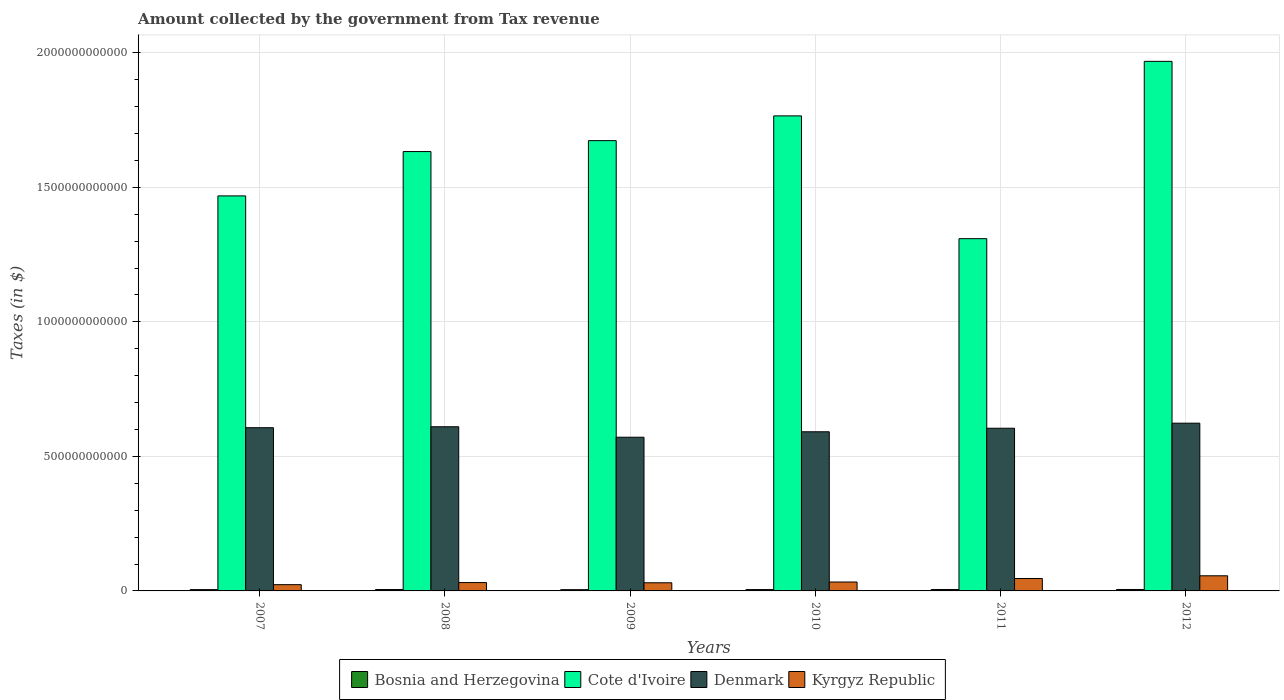How many different coloured bars are there?
Offer a terse response. 4. Are the number of bars per tick equal to the number of legend labels?
Provide a short and direct response. Yes. What is the label of the 3rd group of bars from the left?
Your answer should be very brief. 2009. In how many cases, is the number of bars for a given year not equal to the number of legend labels?
Your answer should be very brief. 0. What is the amount collected by the government from tax revenue in Cote d'Ivoire in 2007?
Your response must be concise. 1.47e+12. Across all years, what is the maximum amount collected by the government from tax revenue in Cote d'Ivoire?
Provide a short and direct response. 1.97e+12. Across all years, what is the minimum amount collected by the government from tax revenue in Kyrgyz Republic?
Ensure brevity in your answer.  2.33e+1. In which year was the amount collected by the government from tax revenue in Cote d'Ivoire maximum?
Give a very brief answer. 2012. In which year was the amount collected by the government from tax revenue in Cote d'Ivoire minimum?
Give a very brief answer. 2011. What is the total amount collected by the government from tax revenue in Cote d'Ivoire in the graph?
Your answer should be very brief. 9.82e+12. What is the difference between the amount collected by the government from tax revenue in Denmark in 2010 and that in 2011?
Make the answer very short. -1.31e+1. What is the difference between the amount collected by the government from tax revenue in Bosnia and Herzegovina in 2007 and the amount collected by the government from tax revenue in Cote d'Ivoire in 2009?
Your answer should be very brief. -1.67e+12. What is the average amount collected by the government from tax revenue in Cote d'Ivoire per year?
Give a very brief answer. 1.64e+12. In the year 2010, what is the difference between the amount collected by the government from tax revenue in Denmark and amount collected by the government from tax revenue in Kyrgyz Republic?
Provide a succinct answer. 5.58e+11. In how many years, is the amount collected by the government from tax revenue in Kyrgyz Republic greater than 1200000000000 $?
Provide a short and direct response. 0. What is the ratio of the amount collected by the government from tax revenue in Cote d'Ivoire in 2009 to that in 2011?
Keep it short and to the point. 1.28. Is the amount collected by the government from tax revenue in Kyrgyz Republic in 2010 less than that in 2011?
Your response must be concise. Yes. What is the difference between the highest and the second highest amount collected by the government from tax revenue in Cote d'Ivoire?
Make the answer very short. 2.03e+11. What is the difference between the highest and the lowest amount collected by the government from tax revenue in Kyrgyz Republic?
Your response must be concise. 3.30e+1. In how many years, is the amount collected by the government from tax revenue in Kyrgyz Republic greater than the average amount collected by the government from tax revenue in Kyrgyz Republic taken over all years?
Give a very brief answer. 2. Is the sum of the amount collected by the government from tax revenue in Kyrgyz Republic in 2009 and 2011 greater than the maximum amount collected by the government from tax revenue in Denmark across all years?
Make the answer very short. No. Is it the case that in every year, the sum of the amount collected by the government from tax revenue in Denmark and amount collected by the government from tax revenue in Cote d'Ivoire is greater than the sum of amount collected by the government from tax revenue in Kyrgyz Republic and amount collected by the government from tax revenue in Bosnia and Herzegovina?
Keep it short and to the point. Yes. What does the 1st bar from the left in 2007 represents?
Make the answer very short. Bosnia and Herzegovina. What does the 1st bar from the right in 2010 represents?
Keep it short and to the point. Kyrgyz Republic. Is it the case that in every year, the sum of the amount collected by the government from tax revenue in Denmark and amount collected by the government from tax revenue in Bosnia and Herzegovina is greater than the amount collected by the government from tax revenue in Kyrgyz Republic?
Make the answer very short. Yes. How many years are there in the graph?
Keep it short and to the point. 6. What is the difference between two consecutive major ticks on the Y-axis?
Provide a short and direct response. 5.00e+11. Are the values on the major ticks of Y-axis written in scientific E-notation?
Give a very brief answer. No. Does the graph contain grids?
Make the answer very short. Yes. Where does the legend appear in the graph?
Offer a very short reply. Bottom center. How are the legend labels stacked?
Make the answer very short. Horizontal. What is the title of the graph?
Your response must be concise. Amount collected by the government from Tax revenue. What is the label or title of the Y-axis?
Provide a short and direct response. Taxes (in $). What is the Taxes (in $) of Bosnia and Herzegovina in 2007?
Provide a succinct answer. 4.82e+09. What is the Taxes (in $) in Cote d'Ivoire in 2007?
Ensure brevity in your answer.  1.47e+12. What is the Taxes (in $) of Denmark in 2007?
Your response must be concise. 6.07e+11. What is the Taxes (in $) of Kyrgyz Republic in 2007?
Ensure brevity in your answer.  2.33e+1. What is the Taxes (in $) in Bosnia and Herzegovina in 2008?
Your response must be concise. 5.18e+09. What is the Taxes (in $) of Cote d'Ivoire in 2008?
Provide a succinct answer. 1.63e+12. What is the Taxes (in $) in Denmark in 2008?
Offer a terse response. 6.10e+11. What is the Taxes (in $) in Kyrgyz Republic in 2008?
Offer a terse response. 3.10e+1. What is the Taxes (in $) of Bosnia and Herzegovina in 2009?
Your answer should be compact. 4.70e+09. What is the Taxes (in $) of Cote d'Ivoire in 2009?
Offer a very short reply. 1.67e+12. What is the Taxes (in $) of Denmark in 2009?
Your answer should be very brief. 5.71e+11. What is the Taxes (in $) of Kyrgyz Republic in 2009?
Offer a terse response. 3.03e+1. What is the Taxes (in $) in Bosnia and Herzegovina in 2010?
Your answer should be very brief. 4.99e+09. What is the Taxes (in $) in Cote d'Ivoire in 2010?
Your answer should be very brief. 1.77e+12. What is the Taxes (in $) in Denmark in 2010?
Make the answer very short. 5.91e+11. What is the Taxes (in $) of Kyrgyz Republic in 2010?
Your answer should be compact. 3.31e+1. What is the Taxes (in $) in Bosnia and Herzegovina in 2011?
Provide a short and direct response. 5.33e+09. What is the Taxes (in $) in Cote d'Ivoire in 2011?
Offer a terse response. 1.31e+12. What is the Taxes (in $) of Denmark in 2011?
Keep it short and to the point. 6.05e+11. What is the Taxes (in $) in Kyrgyz Republic in 2011?
Your response must be concise. 4.61e+1. What is the Taxes (in $) in Bosnia and Herzegovina in 2012?
Your answer should be compact. 5.37e+09. What is the Taxes (in $) in Cote d'Ivoire in 2012?
Make the answer very short. 1.97e+12. What is the Taxes (in $) in Denmark in 2012?
Keep it short and to the point. 6.23e+11. What is the Taxes (in $) of Kyrgyz Republic in 2012?
Provide a succinct answer. 5.62e+1. Across all years, what is the maximum Taxes (in $) in Bosnia and Herzegovina?
Provide a short and direct response. 5.37e+09. Across all years, what is the maximum Taxes (in $) of Cote d'Ivoire?
Provide a succinct answer. 1.97e+12. Across all years, what is the maximum Taxes (in $) in Denmark?
Provide a short and direct response. 6.23e+11. Across all years, what is the maximum Taxes (in $) of Kyrgyz Republic?
Offer a terse response. 5.62e+1. Across all years, what is the minimum Taxes (in $) of Bosnia and Herzegovina?
Your response must be concise. 4.70e+09. Across all years, what is the minimum Taxes (in $) of Cote d'Ivoire?
Offer a very short reply. 1.31e+12. Across all years, what is the minimum Taxes (in $) of Denmark?
Your answer should be very brief. 5.71e+11. Across all years, what is the minimum Taxes (in $) of Kyrgyz Republic?
Offer a terse response. 2.33e+1. What is the total Taxes (in $) in Bosnia and Herzegovina in the graph?
Make the answer very short. 3.04e+1. What is the total Taxes (in $) of Cote d'Ivoire in the graph?
Give a very brief answer. 9.82e+12. What is the total Taxes (in $) in Denmark in the graph?
Your answer should be very brief. 3.61e+12. What is the total Taxes (in $) of Kyrgyz Republic in the graph?
Provide a short and direct response. 2.20e+11. What is the difference between the Taxes (in $) of Bosnia and Herzegovina in 2007 and that in 2008?
Your answer should be compact. -3.57e+08. What is the difference between the Taxes (in $) of Cote d'Ivoire in 2007 and that in 2008?
Offer a terse response. -1.65e+11. What is the difference between the Taxes (in $) in Denmark in 2007 and that in 2008?
Provide a succinct answer. -3.56e+09. What is the difference between the Taxes (in $) in Kyrgyz Republic in 2007 and that in 2008?
Make the answer very short. -7.77e+09. What is the difference between the Taxes (in $) in Bosnia and Herzegovina in 2007 and that in 2009?
Offer a terse response. 1.26e+08. What is the difference between the Taxes (in $) in Cote d'Ivoire in 2007 and that in 2009?
Your answer should be compact. -2.05e+11. What is the difference between the Taxes (in $) of Denmark in 2007 and that in 2009?
Give a very brief answer. 3.54e+1. What is the difference between the Taxes (in $) of Kyrgyz Republic in 2007 and that in 2009?
Your answer should be compact. -6.99e+09. What is the difference between the Taxes (in $) of Bosnia and Herzegovina in 2007 and that in 2010?
Give a very brief answer. -1.69e+08. What is the difference between the Taxes (in $) of Cote d'Ivoire in 2007 and that in 2010?
Provide a short and direct response. -2.97e+11. What is the difference between the Taxes (in $) of Denmark in 2007 and that in 2010?
Offer a very short reply. 1.51e+1. What is the difference between the Taxes (in $) of Kyrgyz Republic in 2007 and that in 2010?
Keep it short and to the point. -9.86e+09. What is the difference between the Taxes (in $) of Bosnia and Herzegovina in 2007 and that in 2011?
Give a very brief answer. -5.02e+08. What is the difference between the Taxes (in $) of Cote d'Ivoire in 2007 and that in 2011?
Make the answer very short. 1.59e+11. What is the difference between the Taxes (in $) in Denmark in 2007 and that in 2011?
Your answer should be very brief. 1.95e+09. What is the difference between the Taxes (in $) in Kyrgyz Republic in 2007 and that in 2011?
Give a very brief answer. -2.29e+1. What is the difference between the Taxes (in $) of Bosnia and Herzegovina in 2007 and that in 2012?
Your answer should be very brief. -5.46e+08. What is the difference between the Taxes (in $) in Cote d'Ivoire in 2007 and that in 2012?
Provide a short and direct response. -5.00e+11. What is the difference between the Taxes (in $) in Denmark in 2007 and that in 2012?
Offer a terse response. -1.68e+1. What is the difference between the Taxes (in $) in Kyrgyz Republic in 2007 and that in 2012?
Your answer should be very brief. -3.30e+1. What is the difference between the Taxes (in $) in Bosnia and Herzegovina in 2008 and that in 2009?
Offer a very short reply. 4.83e+08. What is the difference between the Taxes (in $) in Cote d'Ivoire in 2008 and that in 2009?
Provide a short and direct response. -4.06e+1. What is the difference between the Taxes (in $) of Denmark in 2008 and that in 2009?
Ensure brevity in your answer.  3.89e+1. What is the difference between the Taxes (in $) in Kyrgyz Republic in 2008 and that in 2009?
Offer a terse response. 7.79e+08. What is the difference between the Taxes (in $) in Bosnia and Herzegovina in 2008 and that in 2010?
Your answer should be very brief. 1.88e+08. What is the difference between the Taxes (in $) of Cote d'Ivoire in 2008 and that in 2010?
Ensure brevity in your answer.  -1.33e+11. What is the difference between the Taxes (in $) in Denmark in 2008 and that in 2010?
Your answer should be compact. 1.87e+1. What is the difference between the Taxes (in $) in Kyrgyz Republic in 2008 and that in 2010?
Ensure brevity in your answer.  -2.09e+09. What is the difference between the Taxes (in $) of Bosnia and Herzegovina in 2008 and that in 2011?
Your answer should be compact. -1.45e+08. What is the difference between the Taxes (in $) of Cote d'Ivoire in 2008 and that in 2011?
Give a very brief answer. 3.24e+11. What is the difference between the Taxes (in $) of Denmark in 2008 and that in 2011?
Your answer should be compact. 5.51e+09. What is the difference between the Taxes (in $) in Kyrgyz Republic in 2008 and that in 2011?
Keep it short and to the point. -1.51e+1. What is the difference between the Taxes (in $) of Bosnia and Herzegovina in 2008 and that in 2012?
Your answer should be very brief. -1.89e+08. What is the difference between the Taxes (in $) of Cote d'Ivoire in 2008 and that in 2012?
Make the answer very short. -3.35e+11. What is the difference between the Taxes (in $) in Denmark in 2008 and that in 2012?
Make the answer very short. -1.33e+1. What is the difference between the Taxes (in $) in Kyrgyz Republic in 2008 and that in 2012?
Give a very brief answer. -2.52e+1. What is the difference between the Taxes (in $) in Bosnia and Herzegovina in 2009 and that in 2010?
Offer a very short reply. -2.95e+08. What is the difference between the Taxes (in $) in Cote d'Ivoire in 2009 and that in 2010?
Provide a succinct answer. -9.20e+1. What is the difference between the Taxes (in $) of Denmark in 2009 and that in 2010?
Your answer should be very brief. -2.03e+1. What is the difference between the Taxes (in $) of Kyrgyz Republic in 2009 and that in 2010?
Provide a succinct answer. -2.87e+09. What is the difference between the Taxes (in $) of Bosnia and Herzegovina in 2009 and that in 2011?
Your response must be concise. -6.28e+08. What is the difference between the Taxes (in $) of Cote d'Ivoire in 2009 and that in 2011?
Your answer should be very brief. 3.64e+11. What is the difference between the Taxes (in $) in Denmark in 2009 and that in 2011?
Offer a terse response. -3.34e+1. What is the difference between the Taxes (in $) of Kyrgyz Republic in 2009 and that in 2011?
Give a very brief answer. -1.59e+1. What is the difference between the Taxes (in $) in Bosnia and Herzegovina in 2009 and that in 2012?
Make the answer very short. -6.71e+08. What is the difference between the Taxes (in $) in Cote d'Ivoire in 2009 and that in 2012?
Provide a succinct answer. -2.95e+11. What is the difference between the Taxes (in $) of Denmark in 2009 and that in 2012?
Your answer should be compact. -5.22e+1. What is the difference between the Taxes (in $) of Kyrgyz Republic in 2009 and that in 2012?
Offer a terse response. -2.60e+1. What is the difference between the Taxes (in $) in Bosnia and Herzegovina in 2010 and that in 2011?
Your answer should be compact. -3.33e+08. What is the difference between the Taxes (in $) in Cote d'Ivoire in 2010 and that in 2011?
Make the answer very short. 4.56e+11. What is the difference between the Taxes (in $) in Denmark in 2010 and that in 2011?
Offer a terse response. -1.31e+1. What is the difference between the Taxes (in $) of Kyrgyz Republic in 2010 and that in 2011?
Ensure brevity in your answer.  -1.30e+1. What is the difference between the Taxes (in $) in Bosnia and Herzegovina in 2010 and that in 2012?
Your response must be concise. -3.77e+08. What is the difference between the Taxes (in $) of Cote d'Ivoire in 2010 and that in 2012?
Give a very brief answer. -2.03e+11. What is the difference between the Taxes (in $) of Denmark in 2010 and that in 2012?
Your answer should be very brief. -3.19e+1. What is the difference between the Taxes (in $) in Kyrgyz Republic in 2010 and that in 2012?
Your response must be concise. -2.31e+1. What is the difference between the Taxes (in $) of Bosnia and Herzegovina in 2011 and that in 2012?
Ensure brevity in your answer.  -4.33e+07. What is the difference between the Taxes (in $) of Cote d'Ivoire in 2011 and that in 2012?
Offer a terse response. -6.59e+11. What is the difference between the Taxes (in $) of Denmark in 2011 and that in 2012?
Your response must be concise. -1.88e+1. What is the difference between the Taxes (in $) in Kyrgyz Republic in 2011 and that in 2012?
Offer a very short reply. -1.01e+1. What is the difference between the Taxes (in $) in Bosnia and Herzegovina in 2007 and the Taxes (in $) in Cote d'Ivoire in 2008?
Your response must be concise. -1.63e+12. What is the difference between the Taxes (in $) of Bosnia and Herzegovina in 2007 and the Taxes (in $) of Denmark in 2008?
Keep it short and to the point. -6.05e+11. What is the difference between the Taxes (in $) in Bosnia and Herzegovina in 2007 and the Taxes (in $) in Kyrgyz Republic in 2008?
Your answer should be compact. -2.62e+1. What is the difference between the Taxes (in $) in Cote d'Ivoire in 2007 and the Taxes (in $) in Denmark in 2008?
Offer a very short reply. 8.58e+11. What is the difference between the Taxes (in $) in Cote d'Ivoire in 2007 and the Taxes (in $) in Kyrgyz Republic in 2008?
Your answer should be compact. 1.44e+12. What is the difference between the Taxes (in $) of Denmark in 2007 and the Taxes (in $) of Kyrgyz Republic in 2008?
Keep it short and to the point. 5.76e+11. What is the difference between the Taxes (in $) of Bosnia and Herzegovina in 2007 and the Taxes (in $) of Cote d'Ivoire in 2009?
Your answer should be very brief. -1.67e+12. What is the difference between the Taxes (in $) in Bosnia and Herzegovina in 2007 and the Taxes (in $) in Denmark in 2009?
Offer a very short reply. -5.66e+11. What is the difference between the Taxes (in $) in Bosnia and Herzegovina in 2007 and the Taxes (in $) in Kyrgyz Republic in 2009?
Ensure brevity in your answer.  -2.54e+1. What is the difference between the Taxes (in $) of Cote d'Ivoire in 2007 and the Taxes (in $) of Denmark in 2009?
Give a very brief answer. 8.97e+11. What is the difference between the Taxes (in $) of Cote d'Ivoire in 2007 and the Taxes (in $) of Kyrgyz Republic in 2009?
Offer a terse response. 1.44e+12. What is the difference between the Taxes (in $) of Denmark in 2007 and the Taxes (in $) of Kyrgyz Republic in 2009?
Ensure brevity in your answer.  5.76e+11. What is the difference between the Taxes (in $) of Bosnia and Herzegovina in 2007 and the Taxes (in $) of Cote d'Ivoire in 2010?
Offer a very short reply. -1.76e+12. What is the difference between the Taxes (in $) in Bosnia and Herzegovina in 2007 and the Taxes (in $) in Denmark in 2010?
Give a very brief answer. -5.87e+11. What is the difference between the Taxes (in $) of Bosnia and Herzegovina in 2007 and the Taxes (in $) of Kyrgyz Republic in 2010?
Keep it short and to the point. -2.83e+1. What is the difference between the Taxes (in $) of Cote d'Ivoire in 2007 and the Taxes (in $) of Denmark in 2010?
Your answer should be compact. 8.77e+11. What is the difference between the Taxes (in $) of Cote d'Ivoire in 2007 and the Taxes (in $) of Kyrgyz Republic in 2010?
Give a very brief answer. 1.44e+12. What is the difference between the Taxes (in $) of Denmark in 2007 and the Taxes (in $) of Kyrgyz Republic in 2010?
Your answer should be very brief. 5.73e+11. What is the difference between the Taxes (in $) of Bosnia and Herzegovina in 2007 and the Taxes (in $) of Cote d'Ivoire in 2011?
Offer a terse response. -1.30e+12. What is the difference between the Taxes (in $) of Bosnia and Herzegovina in 2007 and the Taxes (in $) of Denmark in 2011?
Give a very brief answer. -6.00e+11. What is the difference between the Taxes (in $) of Bosnia and Herzegovina in 2007 and the Taxes (in $) of Kyrgyz Republic in 2011?
Make the answer very short. -4.13e+1. What is the difference between the Taxes (in $) of Cote d'Ivoire in 2007 and the Taxes (in $) of Denmark in 2011?
Your answer should be very brief. 8.64e+11. What is the difference between the Taxes (in $) in Cote d'Ivoire in 2007 and the Taxes (in $) in Kyrgyz Republic in 2011?
Your answer should be very brief. 1.42e+12. What is the difference between the Taxes (in $) of Denmark in 2007 and the Taxes (in $) of Kyrgyz Republic in 2011?
Provide a short and direct response. 5.60e+11. What is the difference between the Taxes (in $) of Bosnia and Herzegovina in 2007 and the Taxes (in $) of Cote d'Ivoire in 2012?
Keep it short and to the point. -1.96e+12. What is the difference between the Taxes (in $) of Bosnia and Herzegovina in 2007 and the Taxes (in $) of Denmark in 2012?
Ensure brevity in your answer.  -6.19e+11. What is the difference between the Taxes (in $) of Bosnia and Herzegovina in 2007 and the Taxes (in $) of Kyrgyz Republic in 2012?
Your answer should be very brief. -5.14e+1. What is the difference between the Taxes (in $) in Cote d'Ivoire in 2007 and the Taxes (in $) in Denmark in 2012?
Offer a very short reply. 8.45e+11. What is the difference between the Taxes (in $) of Cote d'Ivoire in 2007 and the Taxes (in $) of Kyrgyz Republic in 2012?
Give a very brief answer. 1.41e+12. What is the difference between the Taxes (in $) in Denmark in 2007 and the Taxes (in $) in Kyrgyz Republic in 2012?
Keep it short and to the point. 5.50e+11. What is the difference between the Taxes (in $) of Bosnia and Herzegovina in 2008 and the Taxes (in $) of Cote d'Ivoire in 2009?
Make the answer very short. -1.67e+12. What is the difference between the Taxes (in $) in Bosnia and Herzegovina in 2008 and the Taxes (in $) in Denmark in 2009?
Your response must be concise. -5.66e+11. What is the difference between the Taxes (in $) in Bosnia and Herzegovina in 2008 and the Taxes (in $) in Kyrgyz Republic in 2009?
Keep it short and to the point. -2.51e+1. What is the difference between the Taxes (in $) in Cote d'Ivoire in 2008 and the Taxes (in $) in Denmark in 2009?
Your response must be concise. 1.06e+12. What is the difference between the Taxes (in $) in Cote d'Ivoire in 2008 and the Taxes (in $) in Kyrgyz Republic in 2009?
Your answer should be very brief. 1.60e+12. What is the difference between the Taxes (in $) of Denmark in 2008 and the Taxes (in $) of Kyrgyz Republic in 2009?
Your answer should be very brief. 5.80e+11. What is the difference between the Taxes (in $) of Bosnia and Herzegovina in 2008 and the Taxes (in $) of Cote d'Ivoire in 2010?
Ensure brevity in your answer.  -1.76e+12. What is the difference between the Taxes (in $) in Bosnia and Herzegovina in 2008 and the Taxes (in $) in Denmark in 2010?
Provide a short and direct response. -5.86e+11. What is the difference between the Taxes (in $) in Bosnia and Herzegovina in 2008 and the Taxes (in $) in Kyrgyz Republic in 2010?
Ensure brevity in your answer.  -2.79e+1. What is the difference between the Taxes (in $) in Cote d'Ivoire in 2008 and the Taxes (in $) in Denmark in 2010?
Your response must be concise. 1.04e+12. What is the difference between the Taxes (in $) in Cote d'Ivoire in 2008 and the Taxes (in $) in Kyrgyz Republic in 2010?
Offer a very short reply. 1.60e+12. What is the difference between the Taxes (in $) in Denmark in 2008 and the Taxes (in $) in Kyrgyz Republic in 2010?
Ensure brevity in your answer.  5.77e+11. What is the difference between the Taxes (in $) of Bosnia and Herzegovina in 2008 and the Taxes (in $) of Cote d'Ivoire in 2011?
Your answer should be very brief. -1.30e+12. What is the difference between the Taxes (in $) in Bosnia and Herzegovina in 2008 and the Taxes (in $) in Denmark in 2011?
Your answer should be very brief. -5.99e+11. What is the difference between the Taxes (in $) of Bosnia and Herzegovina in 2008 and the Taxes (in $) of Kyrgyz Republic in 2011?
Make the answer very short. -4.09e+1. What is the difference between the Taxes (in $) of Cote d'Ivoire in 2008 and the Taxes (in $) of Denmark in 2011?
Your answer should be compact. 1.03e+12. What is the difference between the Taxes (in $) of Cote d'Ivoire in 2008 and the Taxes (in $) of Kyrgyz Republic in 2011?
Your answer should be compact. 1.59e+12. What is the difference between the Taxes (in $) in Denmark in 2008 and the Taxes (in $) in Kyrgyz Republic in 2011?
Make the answer very short. 5.64e+11. What is the difference between the Taxes (in $) in Bosnia and Herzegovina in 2008 and the Taxes (in $) in Cote d'Ivoire in 2012?
Keep it short and to the point. -1.96e+12. What is the difference between the Taxes (in $) in Bosnia and Herzegovina in 2008 and the Taxes (in $) in Denmark in 2012?
Your answer should be compact. -6.18e+11. What is the difference between the Taxes (in $) of Bosnia and Herzegovina in 2008 and the Taxes (in $) of Kyrgyz Republic in 2012?
Your answer should be very brief. -5.11e+1. What is the difference between the Taxes (in $) of Cote d'Ivoire in 2008 and the Taxes (in $) of Denmark in 2012?
Keep it short and to the point. 1.01e+12. What is the difference between the Taxes (in $) of Cote d'Ivoire in 2008 and the Taxes (in $) of Kyrgyz Republic in 2012?
Offer a terse response. 1.58e+12. What is the difference between the Taxes (in $) in Denmark in 2008 and the Taxes (in $) in Kyrgyz Republic in 2012?
Offer a very short reply. 5.54e+11. What is the difference between the Taxes (in $) in Bosnia and Herzegovina in 2009 and the Taxes (in $) in Cote d'Ivoire in 2010?
Keep it short and to the point. -1.76e+12. What is the difference between the Taxes (in $) in Bosnia and Herzegovina in 2009 and the Taxes (in $) in Denmark in 2010?
Your response must be concise. -5.87e+11. What is the difference between the Taxes (in $) of Bosnia and Herzegovina in 2009 and the Taxes (in $) of Kyrgyz Republic in 2010?
Give a very brief answer. -2.84e+1. What is the difference between the Taxes (in $) of Cote d'Ivoire in 2009 and the Taxes (in $) of Denmark in 2010?
Your answer should be compact. 1.08e+12. What is the difference between the Taxes (in $) in Cote d'Ivoire in 2009 and the Taxes (in $) in Kyrgyz Republic in 2010?
Give a very brief answer. 1.64e+12. What is the difference between the Taxes (in $) of Denmark in 2009 and the Taxes (in $) of Kyrgyz Republic in 2010?
Provide a succinct answer. 5.38e+11. What is the difference between the Taxes (in $) of Bosnia and Herzegovina in 2009 and the Taxes (in $) of Cote d'Ivoire in 2011?
Give a very brief answer. -1.30e+12. What is the difference between the Taxes (in $) in Bosnia and Herzegovina in 2009 and the Taxes (in $) in Denmark in 2011?
Your answer should be very brief. -6.00e+11. What is the difference between the Taxes (in $) of Bosnia and Herzegovina in 2009 and the Taxes (in $) of Kyrgyz Republic in 2011?
Give a very brief answer. -4.14e+1. What is the difference between the Taxes (in $) in Cote d'Ivoire in 2009 and the Taxes (in $) in Denmark in 2011?
Give a very brief answer. 1.07e+12. What is the difference between the Taxes (in $) of Cote d'Ivoire in 2009 and the Taxes (in $) of Kyrgyz Republic in 2011?
Provide a short and direct response. 1.63e+12. What is the difference between the Taxes (in $) of Denmark in 2009 and the Taxes (in $) of Kyrgyz Republic in 2011?
Keep it short and to the point. 5.25e+11. What is the difference between the Taxes (in $) of Bosnia and Herzegovina in 2009 and the Taxes (in $) of Cote d'Ivoire in 2012?
Your answer should be very brief. -1.96e+12. What is the difference between the Taxes (in $) of Bosnia and Herzegovina in 2009 and the Taxes (in $) of Denmark in 2012?
Offer a very short reply. -6.19e+11. What is the difference between the Taxes (in $) of Bosnia and Herzegovina in 2009 and the Taxes (in $) of Kyrgyz Republic in 2012?
Your answer should be very brief. -5.15e+1. What is the difference between the Taxes (in $) in Cote d'Ivoire in 2009 and the Taxes (in $) in Denmark in 2012?
Provide a short and direct response. 1.05e+12. What is the difference between the Taxes (in $) in Cote d'Ivoire in 2009 and the Taxes (in $) in Kyrgyz Republic in 2012?
Provide a short and direct response. 1.62e+12. What is the difference between the Taxes (in $) of Denmark in 2009 and the Taxes (in $) of Kyrgyz Republic in 2012?
Offer a terse response. 5.15e+11. What is the difference between the Taxes (in $) of Bosnia and Herzegovina in 2010 and the Taxes (in $) of Cote d'Ivoire in 2011?
Your answer should be very brief. -1.30e+12. What is the difference between the Taxes (in $) in Bosnia and Herzegovina in 2010 and the Taxes (in $) in Denmark in 2011?
Your response must be concise. -6.00e+11. What is the difference between the Taxes (in $) in Bosnia and Herzegovina in 2010 and the Taxes (in $) in Kyrgyz Republic in 2011?
Offer a terse response. -4.11e+1. What is the difference between the Taxes (in $) of Cote d'Ivoire in 2010 and the Taxes (in $) of Denmark in 2011?
Provide a succinct answer. 1.16e+12. What is the difference between the Taxes (in $) in Cote d'Ivoire in 2010 and the Taxes (in $) in Kyrgyz Republic in 2011?
Make the answer very short. 1.72e+12. What is the difference between the Taxes (in $) of Denmark in 2010 and the Taxes (in $) of Kyrgyz Republic in 2011?
Your answer should be compact. 5.45e+11. What is the difference between the Taxes (in $) of Bosnia and Herzegovina in 2010 and the Taxes (in $) of Cote d'Ivoire in 2012?
Provide a succinct answer. -1.96e+12. What is the difference between the Taxes (in $) in Bosnia and Herzegovina in 2010 and the Taxes (in $) in Denmark in 2012?
Offer a very short reply. -6.18e+11. What is the difference between the Taxes (in $) in Bosnia and Herzegovina in 2010 and the Taxes (in $) in Kyrgyz Republic in 2012?
Provide a short and direct response. -5.13e+1. What is the difference between the Taxes (in $) in Cote d'Ivoire in 2010 and the Taxes (in $) in Denmark in 2012?
Your answer should be very brief. 1.14e+12. What is the difference between the Taxes (in $) in Cote d'Ivoire in 2010 and the Taxes (in $) in Kyrgyz Republic in 2012?
Give a very brief answer. 1.71e+12. What is the difference between the Taxes (in $) in Denmark in 2010 and the Taxes (in $) in Kyrgyz Republic in 2012?
Give a very brief answer. 5.35e+11. What is the difference between the Taxes (in $) in Bosnia and Herzegovina in 2011 and the Taxes (in $) in Cote d'Ivoire in 2012?
Provide a succinct answer. -1.96e+12. What is the difference between the Taxes (in $) in Bosnia and Herzegovina in 2011 and the Taxes (in $) in Denmark in 2012?
Provide a short and direct response. -6.18e+11. What is the difference between the Taxes (in $) in Bosnia and Herzegovina in 2011 and the Taxes (in $) in Kyrgyz Republic in 2012?
Ensure brevity in your answer.  -5.09e+1. What is the difference between the Taxes (in $) in Cote d'Ivoire in 2011 and the Taxes (in $) in Denmark in 2012?
Provide a short and direct response. 6.86e+11. What is the difference between the Taxes (in $) in Cote d'Ivoire in 2011 and the Taxes (in $) in Kyrgyz Republic in 2012?
Your response must be concise. 1.25e+12. What is the difference between the Taxes (in $) in Denmark in 2011 and the Taxes (in $) in Kyrgyz Republic in 2012?
Your response must be concise. 5.48e+11. What is the average Taxes (in $) of Bosnia and Herzegovina per year?
Ensure brevity in your answer.  5.07e+09. What is the average Taxes (in $) in Cote d'Ivoire per year?
Offer a very short reply. 1.64e+12. What is the average Taxes (in $) of Denmark per year?
Ensure brevity in your answer.  6.01e+11. What is the average Taxes (in $) of Kyrgyz Republic per year?
Keep it short and to the point. 3.67e+1. In the year 2007, what is the difference between the Taxes (in $) in Bosnia and Herzegovina and Taxes (in $) in Cote d'Ivoire?
Offer a very short reply. -1.46e+12. In the year 2007, what is the difference between the Taxes (in $) of Bosnia and Herzegovina and Taxes (in $) of Denmark?
Keep it short and to the point. -6.02e+11. In the year 2007, what is the difference between the Taxes (in $) of Bosnia and Herzegovina and Taxes (in $) of Kyrgyz Republic?
Offer a very short reply. -1.84e+1. In the year 2007, what is the difference between the Taxes (in $) in Cote d'Ivoire and Taxes (in $) in Denmark?
Your answer should be compact. 8.62e+11. In the year 2007, what is the difference between the Taxes (in $) in Cote d'Ivoire and Taxes (in $) in Kyrgyz Republic?
Provide a short and direct response. 1.44e+12. In the year 2007, what is the difference between the Taxes (in $) of Denmark and Taxes (in $) of Kyrgyz Republic?
Your answer should be compact. 5.83e+11. In the year 2008, what is the difference between the Taxes (in $) in Bosnia and Herzegovina and Taxes (in $) in Cote d'Ivoire?
Offer a terse response. -1.63e+12. In the year 2008, what is the difference between the Taxes (in $) in Bosnia and Herzegovina and Taxes (in $) in Denmark?
Ensure brevity in your answer.  -6.05e+11. In the year 2008, what is the difference between the Taxes (in $) of Bosnia and Herzegovina and Taxes (in $) of Kyrgyz Republic?
Ensure brevity in your answer.  -2.59e+1. In the year 2008, what is the difference between the Taxes (in $) of Cote d'Ivoire and Taxes (in $) of Denmark?
Give a very brief answer. 1.02e+12. In the year 2008, what is the difference between the Taxes (in $) in Cote d'Ivoire and Taxes (in $) in Kyrgyz Republic?
Ensure brevity in your answer.  1.60e+12. In the year 2008, what is the difference between the Taxes (in $) of Denmark and Taxes (in $) of Kyrgyz Republic?
Give a very brief answer. 5.79e+11. In the year 2009, what is the difference between the Taxes (in $) of Bosnia and Herzegovina and Taxes (in $) of Cote d'Ivoire?
Provide a short and direct response. -1.67e+12. In the year 2009, what is the difference between the Taxes (in $) of Bosnia and Herzegovina and Taxes (in $) of Denmark?
Give a very brief answer. -5.67e+11. In the year 2009, what is the difference between the Taxes (in $) of Bosnia and Herzegovina and Taxes (in $) of Kyrgyz Republic?
Offer a terse response. -2.56e+1. In the year 2009, what is the difference between the Taxes (in $) of Cote d'Ivoire and Taxes (in $) of Denmark?
Provide a short and direct response. 1.10e+12. In the year 2009, what is the difference between the Taxes (in $) of Cote d'Ivoire and Taxes (in $) of Kyrgyz Republic?
Provide a succinct answer. 1.64e+12. In the year 2009, what is the difference between the Taxes (in $) in Denmark and Taxes (in $) in Kyrgyz Republic?
Provide a succinct answer. 5.41e+11. In the year 2010, what is the difference between the Taxes (in $) in Bosnia and Herzegovina and Taxes (in $) in Cote d'Ivoire?
Your answer should be compact. -1.76e+12. In the year 2010, what is the difference between the Taxes (in $) in Bosnia and Herzegovina and Taxes (in $) in Denmark?
Ensure brevity in your answer.  -5.87e+11. In the year 2010, what is the difference between the Taxes (in $) of Bosnia and Herzegovina and Taxes (in $) of Kyrgyz Republic?
Ensure brevity in your answer.  -2.81e+1. In the year 2010, what is the difference between the Taxes (in $) in Cote d'Ivoire and Taxes (in $) in Denmark?
Provide a succinct answer. 1.17e+12. In the year 2010, what is the difference between the Taxes (in $) in Cote d'Ivoire and Taxes (in $) in Kyrgyz Republic?
Make the answer very short. 1.73e+12. In the year 2010, what is the difference between the Taxes (in $) of Denmark and Taxes (in $) of Kyrgyz Republic?
Your answer should be very brief. 5.58e+11. In the year 2011, what is the difference between the Taxes (in $) of Bosnia and Herzegovina and Taxes (in $) of Cote d'Ivoire?
Provide a short and direct response. -1.30e+12. In the year 2011, what is the difference between the Taxes (in $) in Bosnia and Herzegovina and Taxes (in $) in Denmark?
Offer a terse response. -5.99e+11. In the year 2011, what is the difference between the Taxes (in $) in Bosnia and Herzegovina and Taxes (in $) in Kyrgyz Republic?
Provide a short and direct response. -4.08e+1. In the year 2011, what is the difference between the Taxes (in $) of Cote d'Ivoire and Taxes (in $) of Denmark?
Your response must be concise. 7.05e+11. In the year 2011, what is the difference between the Taxes (in $) in Cote d'Ivoire and Taxes (in $) in Kyrgyz Republic?
Keep it short and to the point. 1.26e+12. In the year 2011, what is the difference between the Taxes (in $) in Denmark and Taxes (in $) in Kyrgyz Republic?
Ensure brevity in your answer.  5.59e+11. In the year 2012, what is the difference between the Taxes (in $) in Bosnia and Herzegovina and Taxes (in $) in Cote d'Ivoire?
Provide a succinct answer. -1.96e+12. In the year 2012, what is the difference between the Taxes (in $) in Bosnia and Herzegovina and Taxes (in $) in Denmark?
Provide a succinct answer. -6.18e+11. In the year 2012, what is the difference between the Taxes (in $) in Bosnia and Herzegovina and Taxes (in $) in Kyrgyz Republic?
Your answer should be very brief. -5.09e+1. In the year 2012, what is the difference between the Taxes (in $) in Cote d'Ivoire and Taxes (in $) in Denmark?
Provide a short and direct response. 1.34e+12. In the year 2012, what is the difference between the Taxes (in $) in Cote d'Ivoire and Taxes (in $) in Kyrgyz Republic?
Offer a terse response. 1.91e+12. In the year 2012, what is the difference between the Taxes (in $) in Denmark and Taxes (in $) in Kyrgyz Republic?
Offer a very short reply. 5.67e+11. What is the ratio of the Taxes (in $) of Bosnia and Herzegovina in 2007 to that in 2008?
Ensure brevity in your answer.  0.93. What is the ratio of the Taxes (in $) in Cote d'Ivoire in 2007 to that in 2008?
Offer a very short reply. 0.9. What is the ratio of the Taxes (in $) in Kyrgyz Republic in 2007 to that in 2008?
Your answer should be very brief. 0.75. What is the ratio of the Taxes (in $) in Bosnia and Herzegovina in 2007 to that in 2009?
Offer a terse response. 1.03. What is the ratio of the Taxes (in $) of Cote d'Ivoire in 2007 to that in 2009?
Your answer should be compact. 0.88. What is the ratio of the Taxes (in $) of Denmark in 2007 to that in 2009?
Keep it short and to the point. 1.06. What is the ratio of the Taxes (in $) of Kyrgyz Republic in 2007 to that in 2009?
Your answer should be compact. 0.77. What is the ratio of the Taxes (in $) in Bosnia and Herzegovina in 2007 to that in 2010?
Offer a very short reply. 0.97. What is the ratio of the Taxes (in $) in Cote d'Ivoire in 2007 to that in 2010?
Provide a succinct answer. 0.83. What is the ratio of the Taxes (in $) of Denmark in 2007 to that in 2010?
Ensure brevity in your answer.  1.03. What is the ratio of the Taxes (in $) of Kyrgyz Republic in 2007 to that in 2010?
Ensure brevity in your answer.  0.7. What is the ratio of the Taxes (in $) of Bosnia and Herzegovina in 2007 to that in 2011?
Give a very brief answer. 0.91. What is the ratio of the Taxes (in $) of Cote d'Ivoire in 2007 to that in 2011?
Provide a short and direct response. 1.12. What is the ratio of the Taxes (in $) of Kyrgyz Republic in 2007 to that in 2011?
Give a very brief answer. 0.5. What is the ratio of the Taxes (in $) of Bosnia and Herzegovina in 2007 to that in 2012?
Provide a succinct answer. 0.9. What is the ratio of the Taxes (in $) of Cote d'Ivoire in 2007 to that in 2012?
Offer a very short reply. 0.75. What is the ratio of the Taxes (in $) in Kyrgyz Republic in 2007 to that in 2012?
Offer a very short reply. 0.41. What is the ratio of the Taxes (in $) in Bosnia and Herzegovina in 2008 to that in 2009?
Your answer should be compact. 1.1. What is the ratio of the Taxes (in $) in Cote d'Ivoire in 2008 to that in 2009?
Your response must be concise. 0.98. What is the ratio of the Taxes (in $) of Denmark in 2008 to that in 2009?
Make the answer very short. 1.07. What is the ratio of the Taxes (in $) of Kyrgyz Republic in 2008 to that in 2009?
Give a very brief answer. 1.03. What is the ratio of the Taxes (in $) in Bosnia and Herzegovina in 2008 to that in 2010?
Your answer should be compact. 1.04. What is the ratio of the Taxes (in $) of Cote d'Ivoire in 2008 to that in 2010?
Keep it short and to the point. 0.92. What is the ratio of the Taxes (in $) in Denmark in 2008 to that in 2010?
Offer a very short reply. 1.03. What is the ratio of the Taxes (in $) in Kyrgyz Republic in 2008 to that in 2010?
Offer a very short reply. 0.94. What is the ratio of the Taxes (in $) of Bosnia and Herzegovina in 2008 to that in 2011?
Make the answer very short. 0.97. What is the ratio of the Taxes (in $) in Cote d'Ivoire in 2008 to that in 2011?
Give a very brief answer. 1.25. What is the ratio of the Taxes (in $) of Denmark in 2008 to that in 2011?
Your response must be concise. 1.01. What is the ratio of the Taxes (in $) in Kyrgyz Republic in 2008 to that in 2011?
Keep it short and to the point. 0.67. What is the ratio of the Taxes (in $) in Bosnia and Herzegovina in 2008 to that in 2012?
Your response must be concise. 0.96. What is the ratio of the Taxes (in $) in Cote d'Ivoire in 2008 to that in 2012?
Your answer should be compact. 0.83. What is the ratio of the Taxes (in $) of Denmark in 2008 to that in 2012?
Offer a very short reply. 0.98. What is the ratio of the Taxes (in $) of Kyrgyz Republic in 2008 to that in 2012?
Offer a terse response. 0.55. What is the ratio of the Taxes (in $) in Bosnia and Herzegovina in 2009 to that in 2010?
Your answer should be very brief. 0.94. What is the ratio of the Taxes (in $) in Cote d'Ivoire in 2009 to that in 2010?
Make the answer very short. 0.95. What is the ratio of the Taxes (in $) of Denmark in 2009 to that in 2010?
Your answer should be very brief. 0.97. What is the ratio of the Taxes (in $) in Kyrgyz Republic in 2009 to that in 2010?
Your response must be concise. 0.91. What is the ratio of the Taxes (in $) of Bosnia and Herzegovina in 2009 to that in 2011?
Offer a terse response. 0.88. What is the ratio of the Taxes (in $) of Cote d'Ivoire in 2009 to that in 2011?
Make the answer very short. 1.28. What is the ratio of the Taxes (in $) in Denmark in 2009 to that in 2011?
Your answer should be compact. 0.94. What is the ratio of the Taxes (in $) of Kyrgyz Republic in 2009 to that in 2011?
Provide a succinct answer. 0.66. What is the ratio of the Taxes (in $) of Cote d'Ivoire in 2009 to that in 2012?
Offer a terse response. 0.85. What is the ratio of the Taxes (in $) in Denmark in 2009 to that in 2012?
Make the answer very short. 0.92. What is the ratio of the Taxes (in $) in Kyrgyz Republic in 2009 to that in 2012?
Make the answer very short. 0.54. What is the ratio of the Taxes (in $) of Bosnia and Herzegovina in 2010 to that in 2011?
Offer a very short reply. 0.94. What is the ratio of the Taxes (in $) in Cote d'Ivoire in 2010 to that in 2011?
Give a very brief answer. 1.35. What is the ratio of the Taxes (in $) in Denmark in 2010 to that in 2011?
Keep it short and to the point. 0.98. What is the ratio of the Taxes (in $) in Kyrgyz Republic in 2010 to that in 2011?
Offer a very short reply. 0.72. What is the ratio of the Taxes (in $) in Bosnia and Herzegovina in 2010 to that in 2012?
Your response must be concise. 0.93. What is the ratio of the Taxes (in $) of Cote d'Ivoire in 2010 to that in 2012?
Your answer should be very brief. 0.9. What is the ratio of the Taxes (in $) of Denmark in 2010 to that in 2012?
Make the answer very short. 0.95. What is the ratio of the Taxes (in $) of Kyrgyz Republic in 2010 to that in 2012?
Your response must be concise. 0.59. What is the ratio of the Taxes (in $) in Cote d'Ivoire in 2011 to that in 2012?
Make the answer very short. 0.67. What is the ratio of the Taxes (in $) of Denmark in 2011 to that in 2012?
Ensure brevity in your answer.  0.97. What is the ratio of the Taxes (in $) of Kyrgyz Republic in 2011 to that in 2012?
Your response must be concise. 0.82. What is the difference between the highest and the second highest Taxes (in $) in Bosnia and Herzegovina?
Your answer should be very brief. 4.33e+07. What is the difference between the highest and the second highest Taxes (in $) of Cote d'Ivoire?
Make the answer very short. 2.03e+11. What is the difference between the highest and the second highest Taxes (in $) in Denmark?
Your answer should be very brief. 1.33e+1. What is the difference between the highest and the second highest Taxes (in $) of Kyrgyz Republic?
Your answer should be very brief. 1.01e+1. What is the difference between the highest and the lowest Taxes (in $) in Bosnia and Herzegovina?
Make the answer very short. 6.71e+08. What is the difference between the highest and the lowest Taxes (in $) of Cote d'Ivoire?
Offer a terse response. 6.59e+11. What is the difference between the highest and the lowest Taxes (in $) in Denmark?
Provide a short and direct response. 5.22e+1. What is the difference between the highest and the lowest Taxes (in $) of Kyrgyz Republic?
Your answer should be compact. 3.30e+1. 